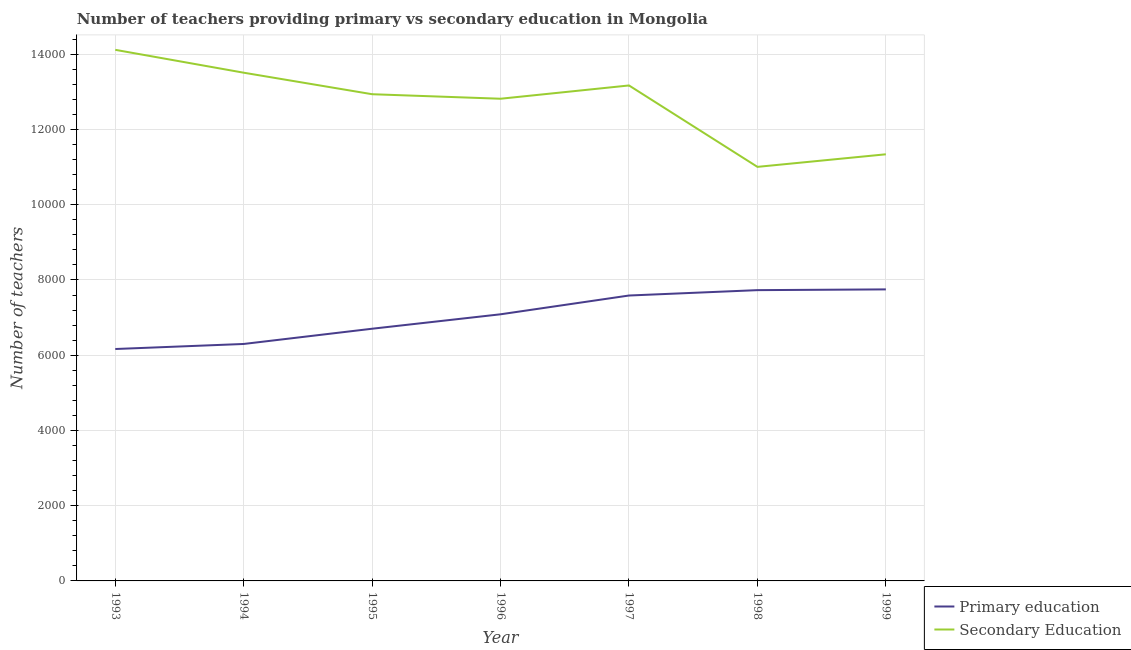How many different coloured lines are there?
Provide a short and direct response. 2. What is the number of secondary teachers in 1993?
Provide a succinct answer. 1.41e+04. Across all years, what is the maximum number of secondary teachers?
Give a very brief answer. 1.41e+04. Across all years, what is the minimum number of primary teachers?
Your response must be concise. 6165. In which year was the number of primary teachers minimum?
Offer a very short reply. 1993. What is the total number of primary teachers in the graph?
Your answer should be very brief. 4.93e+04. What is the difference between the number of secondary teachers in 1997 and that in 1998?
Ensure brevity in your answer.  2164. What is the difference between the number of primary teachers in 1997 and the number of secondary teachers in 1995?
Your response must be concise. -5351. What is the average number of secondary teachers per year?
Keep it short and to the point. 1.27e+04. In the year 1996, what is the difference between the number of secondary teachers and number of primary teachers?
Provide a short and direct response. 5730. In how many years, is the number of primary teachers greater than 1600?
Give a very brief answer. 7. What is the ratio of the number of primary teachers in 1997 to that in 1999?
Your answer should be very brief. 0.98. Is the number of primary teachers in 1993 less than that in 1999?
Provide a short and direct response. Yes. What is the difference between the highest and the second highest number of primary teachers?
Offer a very short reply. 20. What is the difference between the highest and the lowest number of primary teachers?
Provide a succinct answer. 1585. Does the number of secondary teachers monotonically increase over the years?
Provide a short and direct response. No. Is the number of primary teachers strictly greater than the number of secondary teachers over the years?
Provide a succinct answer. No. How many lines are there?
Ensure brevity in your answer.  2. Does the graph contain any zero values?
Ensure brevity in your answer.  No. Where does the legend appear in the graph?
Give a very brief answer. Bottom right. What is the title of the graph?
Offer a terse response. Number of teachers providing primary vs secondary education in Mongolia. Does "IMF concessional" appear as one of the legend labels in the graph?
Provide a short and direct response. No. What is the label or title of the Y-axis?
Offer a terse response. Number of teachers. What is the Number of teachers of Primary education in 1993?
Your answer should be compact. 6165. What is the Number of teachers of Secondary Education in 1993?
Keep it short and to the point. 1.41e+04. What is the Number of teachers of Primary education in 1994?
Provide a succinct answer. 6299. What is the Number of teachers of Secondary Education in 1994?
Provide a succinct answer. 1.35e+04. What is the Number of teachers of Primary education in 1995?
Make the answer very short. 6704. What is the Number of teachers of Secondary Education in 1995?
Ensure brevity in your answer.  1.29e+04. What is the Number of teachers of Primary education in 1996?
Your answer should be very brief. 7088. What is the Number of teachers of Secondary Education in 1996?
Your response must be concise. 1.28e+04. What is the Number of teachers in Primary education in 1997?
Your answer should be compact. 7587. What is the Number of teachers in Secondary Education in 1997?
Your answer should be very brief. 1.32e+04. What is the Number of teachers of Primary education in 1998?
Ensure brevity in your answer.  7730. What is the Number of teachers in Secondary Education in 1998?
Make the answer very short. 1.10e+04. What is the Number of teachers in Primary education in 1999?
Offer a very short reply. 7750. What is the Number of teachers in Secondary Education in 1999?
Offer a very short reply. 1.13e+04. Across all years, what is the maximum Number of teachers of Primary education?
Your response must be concise. 7750. Across all years, what is the maximum Number of teachers in Secondary Education?
Your answer should be very brief. 1.41e+04. Across all years, what is the minimum Number of teachers in Primary education?
Keep it short and to the point. 6165. Across all years, what is the minimum Number of teachers in Secondary Education?
Offer a very short reply. 1.10e+04. What is the total Number of teachers of Primary education in the graph?
Offer a terse response. 4.93e+04. What is the total Number of teachers of Secondary Education in the graph?
Your answer should be very brief. 8.89e+04. What is the difference between the Number of teachers of Primary education in 1993 and that in 1994?
Your answer should be very brief. -134. What is the difference between the Number of teachers of Secondary Education in 1993 and that in 1994?
Offer a terse response. 608. What is the difference between the Number of teachers in Primary education in 1993 and that in 1995?
Provide a short and direct response. -539. What is the difference between the Number of teachers in Secondary Education in 1993 and that in 1995?
Provide a short and direct response. 1180. What is the difference between the Number of teachers in Primary education in 1993 and that in 1996?
Provide a short and direct response. -923. What is the difference between the Number of teachers of Secondary Education in 1993 and that in 1996?
Offer a terse response. 1300. What is the difference between the Number of teachers in Primary education in 1993 and that in 1997?
Give a very brief answer. -1422. What is the difference between the Number of teachers of Secondary Education in 1993 and that in 1997?
Make the answer very short. 947. What is the difference between the Number of teachers in Primary education in 1993 and that in 1998?
Provide a succinct answer. -1565. What is the difference between the Number of teachers in Secondary Education in 1993 and that in 1998?
Keep it short and to the point. 3111. What is the difference between the Number of teachers in Primary education in 1993 and that in 1999?
Offer a terse response. -1585. What is the difference between the Number of teachers of Secondary Education in 1993 and that in 1999?
Your answer should be very brief. 2777. What is the difference between the Number of teachers in Primary education in 1994 and that in 1995?
Your response must be concise. -405. What is the difference between the Number of teachers of Secondary Education in 1994 and that in 1995?
Provide a short and direct response. 572. What is the difference between the Number of teachers in Primary education in 1994 and that in 1996?
Keep it short and to the point. -789. What is the difference between the Number of teachers in Secondary Education in 1994 and that in 1996?
Your response must be concise. 692. What is the difference between the Number of teachers of Primary education in 1994 and that in 1997?
Ensure brevity in your answer.  -1288. What is the difference between the Number of teachers of Secondary Education in 1994 and that in 1997?
Your answer should be compact. 339. What is the difference between the Number of teachers in Primary education in 1994 and that in 1998?
Your response must be concise. -1431. What is the difference between the Number of teachers of Secondary Education in 1994 and that in 1998?
Provide a succinct answer. 2503. What is the difference between the Number of teachers of Primary education in 1994 and that in 1999?
Your response must be concise. -1451. What is the difference between the Number of teachers in Secondary Education in 1994 and that in 1999?
Your answer should be very brief. 2169. What is the difference between the Number of teachers of Primary education in 1995 and that in 1996?
Your response must be concise. -384. What is the difference between the Number of teachers in Secondary Education in 1995 and that in 1996?
Your response must be concise. 120. What is the difference between the Number of teachers of Primary education in 1995 and that in 1997?
Provide a succinct answer. -883. What is the difference between the Number of teachers in Secondary Education in 1995 and that in 1997?
Your answer should be compact. -233. What is the difference between the Number of teachers of Primary education in 1995 and that in 1998?
Ensure brevity in your answer.  -1026. What is the difference between the Number of teachers of Secondary Education in 1995 and that in 1998?
Offer a very short reply. 1931. What is the difference between the Number of teachers in Primary education in 1995 and that in 1999?
Keep it short and to the point. -1046. What is the difference between the Number of teachers in Secondary Education in 1995 and that in 1999?
Give a very brief answer. 1597. What is the difference between the Number of teachers in Primary education in 1996 and that in 1997?
Your answer should be compact. -499. What is the difference between the Number of teachers in Secondary Education in 1996 and that in 1997?
Offer a very short reply. -353. What is the difference between the Number of teachers of Primary education in 1996 and that in 1998?
Make the answer very short. -642. What is the difference between the Number of teachers of Secondary Education in 1996 and that in 1998?
Provide a short and direct response. 1811. What is the difference between the Number of teachers of Primary education in 1996 and that in 1999?
Your answer should be very brief. -662. What is the difference between the Number of teachers in Secondary Education in 1996 and that in 1999?
Give a very brief answer. 1477. What is the difference between the Number of teachers in Primary education in 1997 and that in 1998?
Offer a very short reply. -143. What is the difference between the Number of teachers in Secondary Education in 1997 and that in 1998?
Provide a succinct answer. 2164. What is the difference between the Number of teachers in Primary education in 1997 and that in 1999?
Your answer should be compact. -163. What is the difference between the Number of teachers in Secondary Education in 1997 and that in 1999?
Provide a short and direct response. 1830. What is the difference between the Number of teachers in Secondary Education in 1998 and that in 1999?
Your answer should be very brief. -334. What is the difference between the Number of teachers in Primary education in 1993 and the Number of teachers in Secondary Education in 1994?
Your answer should be very brief. -7345. What is the difference between the Number of teachers of Primary education in 1993 and the Number of teachers of Secondary Education in 1995?
Ensure brevity in your answer.  -6773. What is the difference between the Number of teachers of Primary education in 1993 and the Number of teachers of Secondary Education in 1996?
Provide a succinct answer. -6653. What is the difference between the Number of teachers in Primary education in 1993 and the Number of teachers in Secondary Education in 1997?
Your response must be concise. -7006. What is the difference between the Number of teachers in Primary education in 1993 and the Number of teachers in Secondary Education in 1998?
Keep it short and to the point. -4842. What is the difference between the Number of teachers in Primary education in 1993 and the Number of teachers in Secondary Education in 1999?
Provide a short and direct response. -5176. What is the difference between the Number of teachers in Primary education in 1994 and the Number of teachers in Secondary Education in 1995?
Offer a very short reply. -6639. What is the difference between the Number of teachers in Primary education in 1994 and the Number of teachers in Secondary Education in 1996?
Your response must be concise. -6519. What is the difference between the Number of teachers in Primary education in 1994 and the Number of teachers in Secondary Education in 1997?
Your response must be concise. -6872. What is the difference between the Number of teachers in Primary education in 1994 and the Number of teachers in Secondary Education in 1998?
Your response must be concise. -4708. What is the difference between the Number of teachers of Primary education in 1994 and the Number of teachers of Secondary Education in 1999?
Provide a short and direct response. -5042. What is the difference between the Number of teachers of Primary education in 1995 and the Number of teachers of Secondary Education in 1996?
Provide a succinct answer. -6114. What is the difference between the Number of teachers in Primary education in 1995 and the Number of teachers in Secondary Education in 1997?
Give a very brief answer. -6467. What is the difference between the Number of teachers of Primary education in 1995 and the Number of teachers of Secondary Education in 1998?
Provide a short and direct response. -4303. What is the difference between the Number of teachers in Primary education in 1995 and the Number of teachers in Secondary Education in 1999?
Your answer should be very brief. -4637. What is the difference between the Number of teachers in Primary education in 1996 and the Number of teachers in Secondary Education in 1997?
Offer a very short reply. -6083. What is the difference between the Number of teachers in Primary education in 1996 and the Number of teachers in Secondary Education in 1998?
Your answer should be very brief. -3919. What is the difference between the Number of teachers of Primary education in 1996 and the Number of teachers of Secondary Education in 1999?
Offer a very short reply. -4253. What is the difference between the Number of teachers in Primary education in 1997 and the Number of teachers in Secondary Education in 1998?
Provide a short and direct response. -3420. What is the difference between the Number of teachers of Primary education in 1997 and the Number of teachers of Secondary Education in 1999?
Ensure brevity in your answer.  -3754. What is the difference between the Number of teachers in Primary education in 1998 and the Number of teachers in Secondary Education in 1999?
Ensure brevity in your answer.  -3611. What is the average Number of teachers in Primary education per year?
Offer a terse response. 7046.14. What is the average Number of teachers in Secondary Education per year?
Your answer should be compact. 1.27e+04. In the year 1993, what is the difference between the Number of teachers in Primary education and Number of teachers in Secondary Education?
Provide a short and direct response. -7953. In the year 1994, what is the difference between the Number of teachers of Primary education and Number of teachers of Secondary Education?
Ensure brevity in your answer.  -7211. In the year 1995, what is the difference between the Number of teachers of Primary education and Number of teachers of Secondary Education?
Offer a terse response. -6234. In the year 1996, what is the difference between the Number of teachers in Primary education and Number of teachers in Secondary Education?
Provide a short and direct response. -5730. In the year 1997, what is the difference between the Number of teachers in Primary education and Number of teachers in Secondary Education?
Ensure brevity in your answer.  -5584. In the year 1998, what is the difference between the Number of teachers in Primary education and Number of teachers in Secondary Education?
Your answer should be compact. -3277. In the year 1999, what is the difference between the Number of teachers in Primary education and Number of teachers in Secondary Education?
Offer a terse response. -3591. What is the ratio of the Number of teachers of Primary education in 1993 to that in 1994?
Your response must be concise. 0.98. What is the ratio of the Number of teachers of Secondary Education in 1993 to that in 1994?
Your response must be concise. 1.04. What is the ratio of the Number of teachers of Primary education in 1993 to that in 1995?
Make the answer very short. 0.92. What is the ratio of the Number of teachers of Secondary Education in 1993 to that in 1995?
Give a very brief answer. 1.09. What is the ratio of the Number of teachers of Primary education in 1993 to that in 1996?
Make the answer very short. 0.87. What is the ratio of the Number of teachers in Secondary Education in 1993 to that in 1996?
Give a very brief answer. 1.1. What is the ratio of the Number of teachers in Primary education in 1993 to that in 1997?
Give a very brief answer. 0.81. What is the ratio of the Number of teachers of Secondary Education in 1993 to that in 1997?
Offer a very short reply. 1.07. What is the ratio of the Number of teachers of Primary education in 1993 to that in 1998?
Your response must be concise. 0.8. What is the ratio of the Number of teachers of Secondary Education in 1993 to that in 1998?
Your response must be concise. 1.28. What is the ratio of the Number of teachers in Primary education in 1993 to that in 1999?
Ensure brevity in your answer.  0.8. What is the ratio of the Number of teachers in Secondary Education in 1993 to that in 1999?
Your answer should be very brief. 1.24. What is the ratio of the Number of teachers in Primary education in 1994 to that in 1995?
Offer a terse response. 0.94. What is the ratio of the Number of teachers of Secondary Education in 1994 to that in 1995?
Provide a short and direct response. 1.04. What is the ratio of the Number of teachers in Primary education in 1994 to that in 1996?
Offer a terse response. 0.89. What is the ratio of the Number of teachers in Secondary Education in 1994 to that in 1996?
Your answer should be very brief. 1.05. What is the ratio of the Number of teachers in Primary education in 1994 to that in 1997?
Provide a succinct answer. 0.83. What is the ratio of the Number of teachers in Secondary Education in 1994 to that in 1997?
Offer a very short reply. 1.03. What is the ratio of the Number of teachers in Primary education in 1994 to that in 1998?
Offer a terse response. 0.81. What is the ratio of the Number of teachers of Secondary Education in 1994 to that in 1998?
Make the answer very short. 1.23. What is the ratio of the Number of teachers in Primary education in 1994 to that in 1999?
Give a very brief answer. 0.81. What is the ratio of the Number of teachers of Secondary Education in 1994 to that in 1999?
Offer a terse response. 1.19. What is the ratio of the Number of teachers in Primary education in 1995 to that in 1996?
Your answer should be very brief. 0.95. What is the ratio of the Number of teachers of Secondary Education in 1995 to that in 1996?
Keep it short and to the point. 1.01. What is the ratio of the Number of teachers in Primary education in 1995 to that in 1997?
Offer a very short reply. 0.88. What is the ratio of the Number of teachers in Secondary Education in 1995 to that in 1997?
Provide a succinct answer. 0.98. What is the ratio of the Number of teachers in Primary education in 1995 to that in 1998?
Give a very brief answer. 0.87. What is the ratio of the Number of teachers in Secondary Education in 1995 to that in 1998?
Your response must be concise. 1.18. What is the ratio of the Number of teachers of Primary education in 1995 to that in 1999?
Provide a succinct answer. 0.86. What is the ratio of the Number of teachers of Secondary Education in 1995 to that in 1999?
Ensure brevity in your answer.  1.14. What is the ratio of the Number of teachers of Primary education in 1996 to that in 1997?
Your answer should be compact. 0.93. What is the ratio of the Number of teachers of Secondary Education in 1996 to that in 1997?
Provide a succinct answer. 0.97. What is the ratio of the Number of teachers of Primary education in 1996 to that in 1998?
Your answer should be compact. 0.92. What is the ratio of the Number of teachers of Secondary Education in 1996 to that in 1998?
Ensure brevity in your answer.  1.16. What is the ratio of the Number of teachers in Primary education in 1996 to that in 1999?
Make the answer very short. 0.91. What is the ratio of the Number of teachers of Secondary Education in 1996 to that in 1999?
Ensure brevity in your answer.  1.13. What is the ratio of the Number of teachers of Primary education in 1997 to that in 1998?
Your answer should be compact. 0.98. What is the ratio of the Number of teachers of Secondary Education in 1997 to that in 1998?
Offer a very short reply. 1.2. What is the ratio of the Number of teachers in Secondary Education in 1997 to that in 1999?
Provide a succinct answer. 1.16. What is the ratio of the Number of teachers of Secondary Education in 1998 to that in 1999?
Offer a very short reply. 0.97. What is the difference between the highest and the second highest Number of teachers in Primary education?
Your answer should be very brief. 20. What is the difference between the highest and the second highest Number of teachers of Secondary Education?
Ensure brevity in your answer.  608. What is the difference between the highest and the lowest Number of teachers in Primary education?
Ensure brevity in your answer.  1585. What is the difference between the highest and the lowest Number of teachers in Secondary Education?
Ensure brevity in your answer.  3111. 